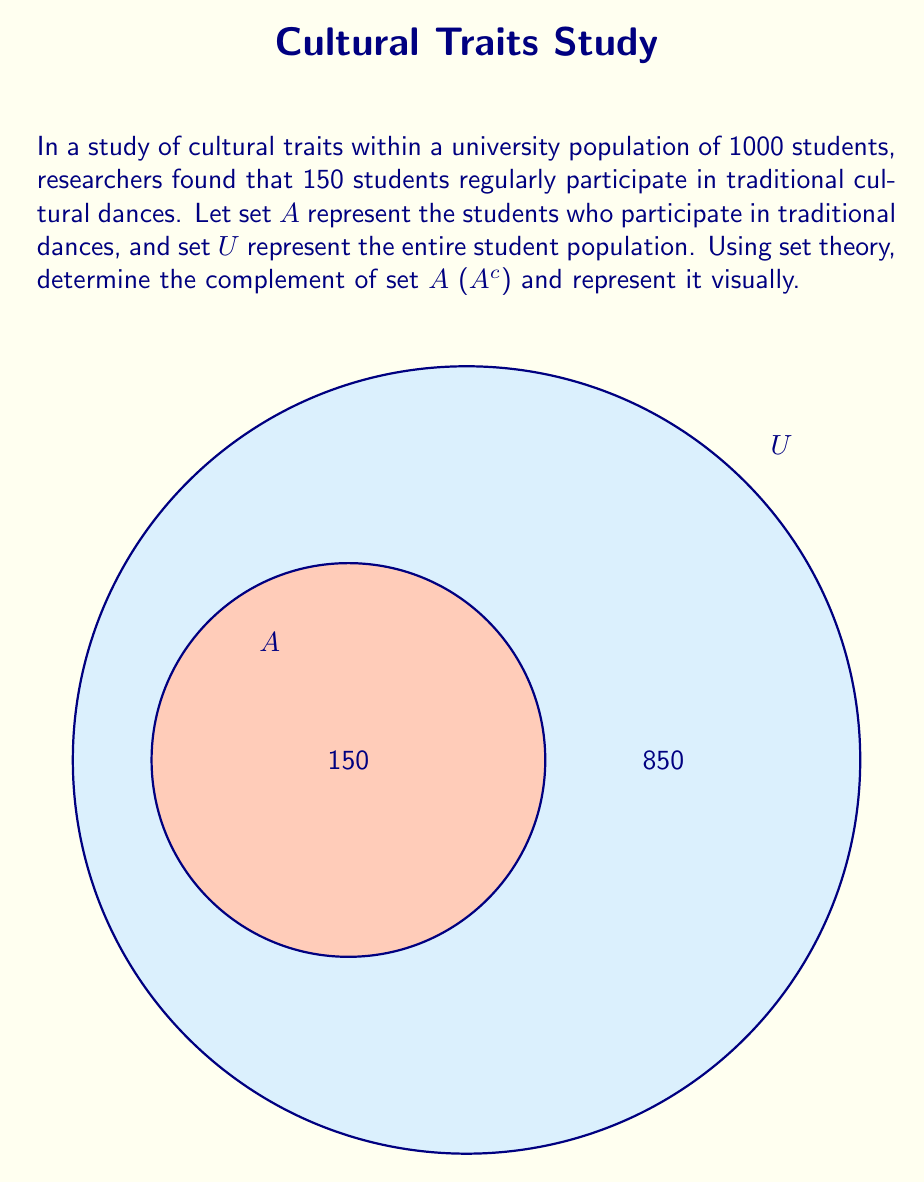Solve this math problem. To solve this problem, we'll follow these steps:

1) First, recall that the complement of a set $A$ within a universal set $U$ is defined as all elements in $U$ that are not in $A$. We denote this as $A^c$.

2) Mathematically, we can express this as:
   $A^c = U \setminus A$

3) In this case:
   $|U| = 1000$ (total number of students)
   $|A| = 150$ (students who participate in traditional dances)

4) To find $|A^c|$, we subtract $|A|$ from $|U|$:
   $|A^c| = |U| - |A| = 1000 - 150 = 850$

5) Therefore, $A^c$ represents the set of 850 students who do not regularly participate in traditional cultural dances.

6) In set theory notation, we can write:
   $A^c = \{x \in U : x \notin A\}$

7) The visual representation in the question shows $U$ as the larger circle (representing all 1000 students) and $A$ as the smaller circle within $U$ (representing the 150 students who participate in traditional dances). The area outside of $A$ but still within $U$ represents $A^c$, which contains 850 students.
Answer: $A^c = \{x \in U : x \notin A\}$, with $|A^c| = 850$ 